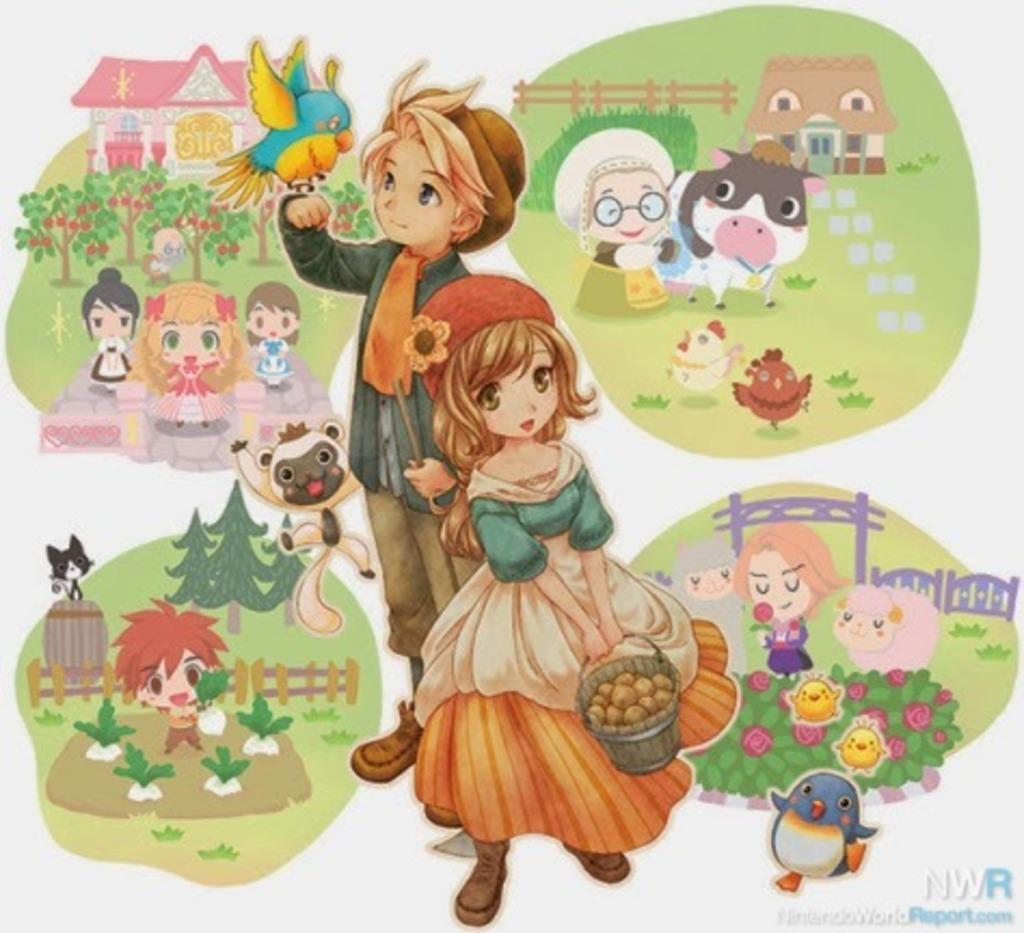What type of pictures are present in the image? The image contains cartoon pictures. What type of pizzas can be seen in the image? There are no pizzas present in the image; it contains cartoon pictures. What type of teeth can be seen in the image? There are no teeth visible in the image, as it features cartoon pictures and teeth are not a part of cartoon characters. 